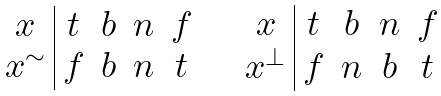<formula> <loc_0><loc_0><loc_500><loc_500>\begin{array} { c | c c c c } x & t & b & n & f \\ x ^ { \sim } & f & b & n & t \end{array} \quad \begin{array} { c | c c c c } x & t & b & n & f \\ x ^ { \bot } & f & n & b & t \end{array}</formula> 